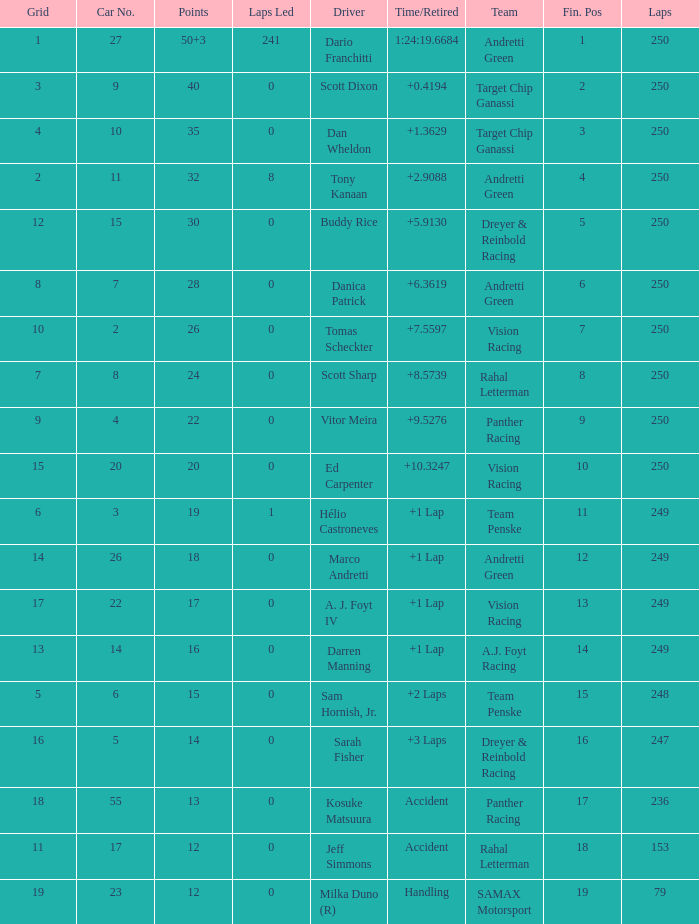Name the least grid for 17 points  17.0. 